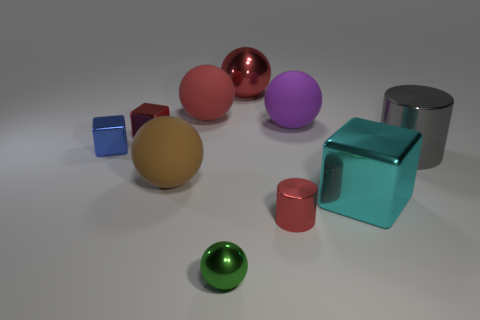What is the small object that is right of the tiny green sphere in front of the tiny shiny thing that is to the right of the big red metal ball made of?
Your answer should be compact. Metal. There is a block that is the same color as the tiny cylinder; what is its material?
Your answer should be very brief. Metal. How many small red cylinders are the same material as the large cylinder?
Keep it short and to the point. 1. There is a red ball that is to the right of the green sphere; is its size the same as the brown matte ball?
Offer a terse response. Yes. There is a large cube that is the same material as the tiny cylinder; what is its color?
Offer a terse response. Cyan. Is there anything else that is the same size as the green thing?
Your response must be concise. Yes. There is a small cylinder; how many big shiny blocks are in front of it?
Provide a short and direct response. 0. There is a large object behind the red rubber sphere; does it have the same color as the large matte object that is behind the big purple matte thing?
Offer a terse response. Yes. The big thing that is the same shape as the small blue metal object is what color?
Your response must be concise. Cyan. Are there any other things that have the same shape as the big gray shiny object?
Provide a short and direct response. Yes. 